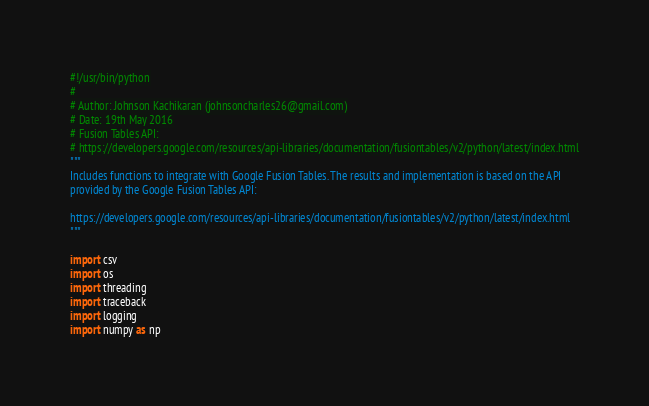<code> <loc_0><loc_0><loc_500><loc_500><_Python_>#!/usr/bin/python
#
# Author: Johnson Kachikaran (johnsoncharles26@gmail.com)
# Date: 19th May 2016
# Fusion Tables API:
# https://developers.google.com/resources/api-libraries/documentation/fusiontables/v2/python/latest/index.html
"""
Includes functions to integrate with Google Fusion Tables. The results and implementation is based on the API
provided by the Google Fusion Tables API:

https://developers.google.com/resources/api-libraries/documentation/fusiontables/v2/python/latest/index.html
"""

import csv
import os
import threading
import traceback
import logging
import numpy as np
</code> 